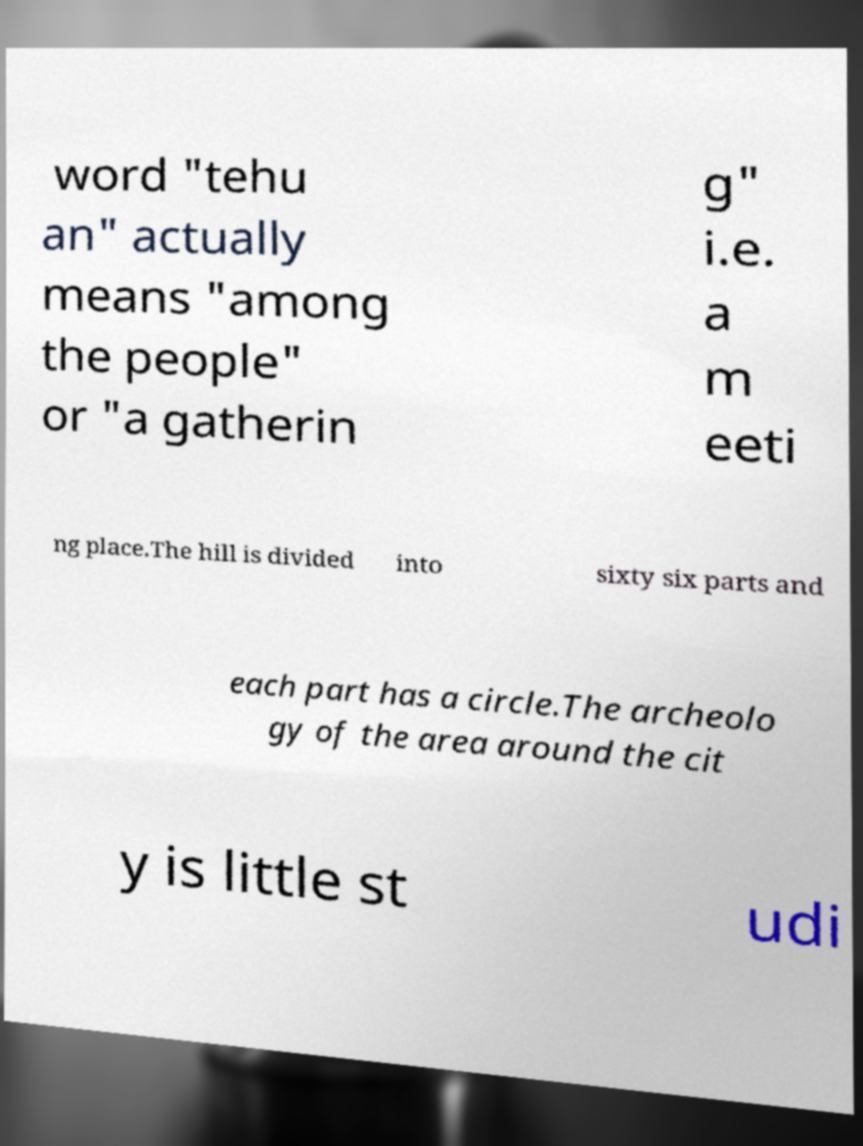Can you accurately transcribe the text from the provided image for me? word "tehu an" actually means "among the people" or "a gatherin g" i.e. a m eeti ng place.The hill is divided into sixty six parts and each part has a circle.The archeolo gy of the area around the cit y is little st udi 